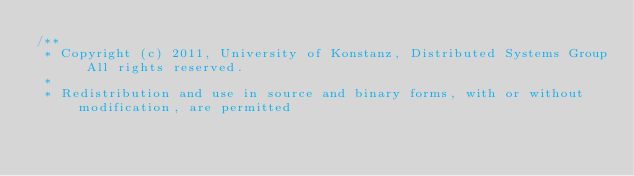<code> <loc_0><loc_0><loc_500><loc_500><_Java_>/**
 * Copyright (c) 2011, University of Konstanz, Distributed Systems Group All rights reserved.
 *
 * Redistribution and use in source and binary forms, with or without modification, are permitted</code> 